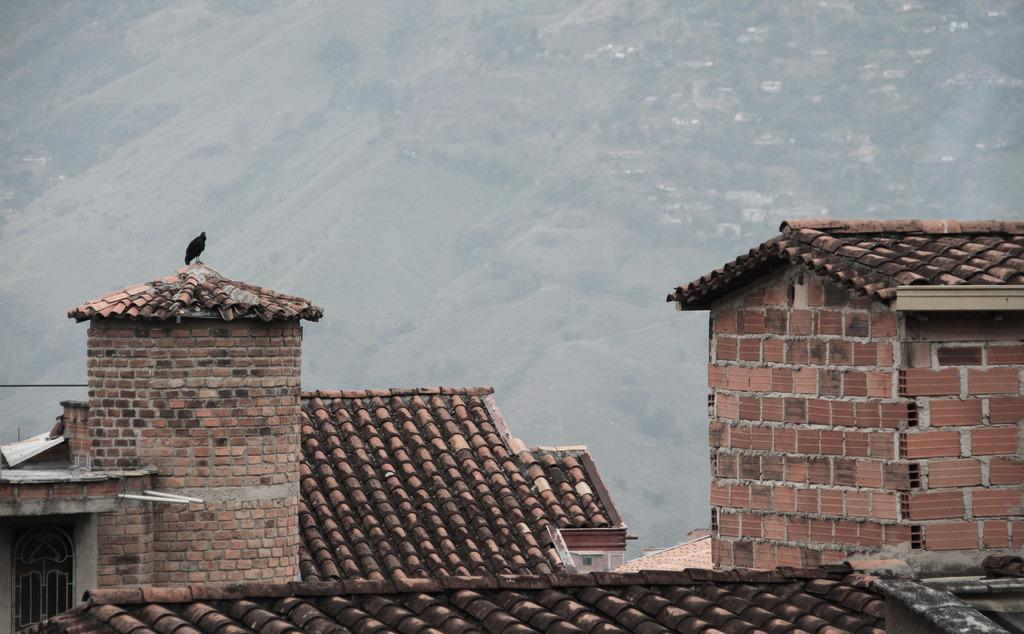What type of structures are present in the image? There are buildings in the image. What color are the rooftops of the buildings? The rooftops of the buildings are red in color. What can be seen in the distance behind the buildings? There are hills visible in the background of the image. What type of animal is present in the image? There is a bird in the image. What type of oven is visible in the image? There is no oven present in the image. What advice might the grandfather give to the bird in the image? There is no grandfather present in the image, so it is not possible to determine what advice he might give to the bird. 